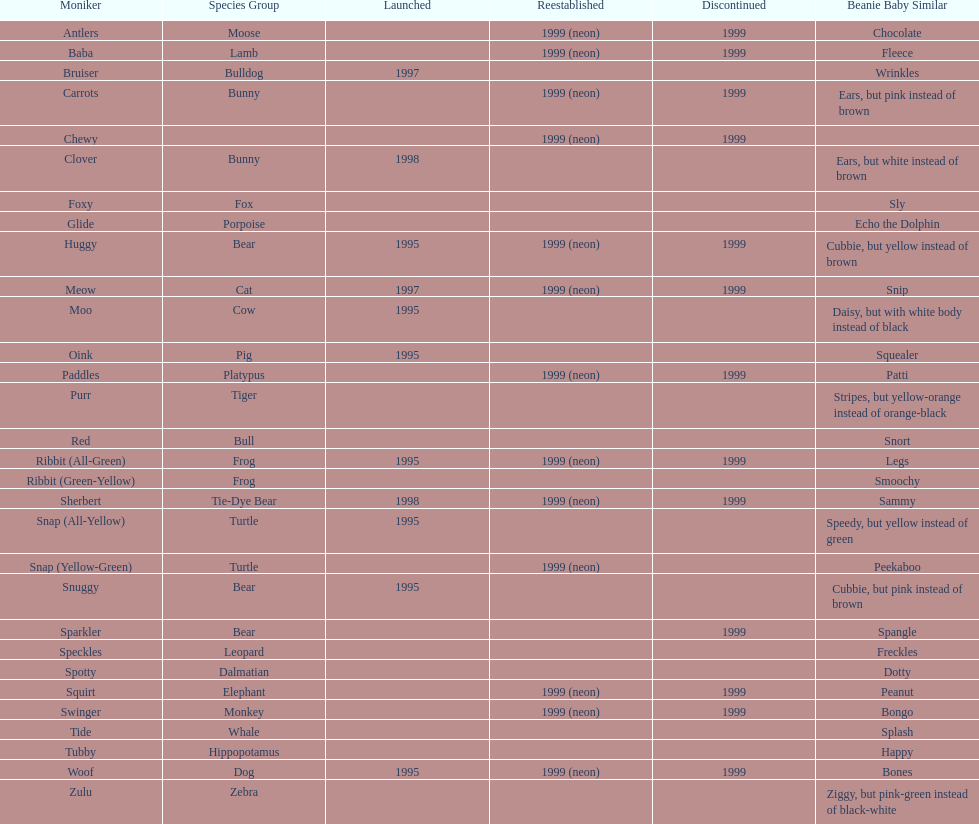How many total pillow pals were both reintroduced and retired in 1999? 12. 